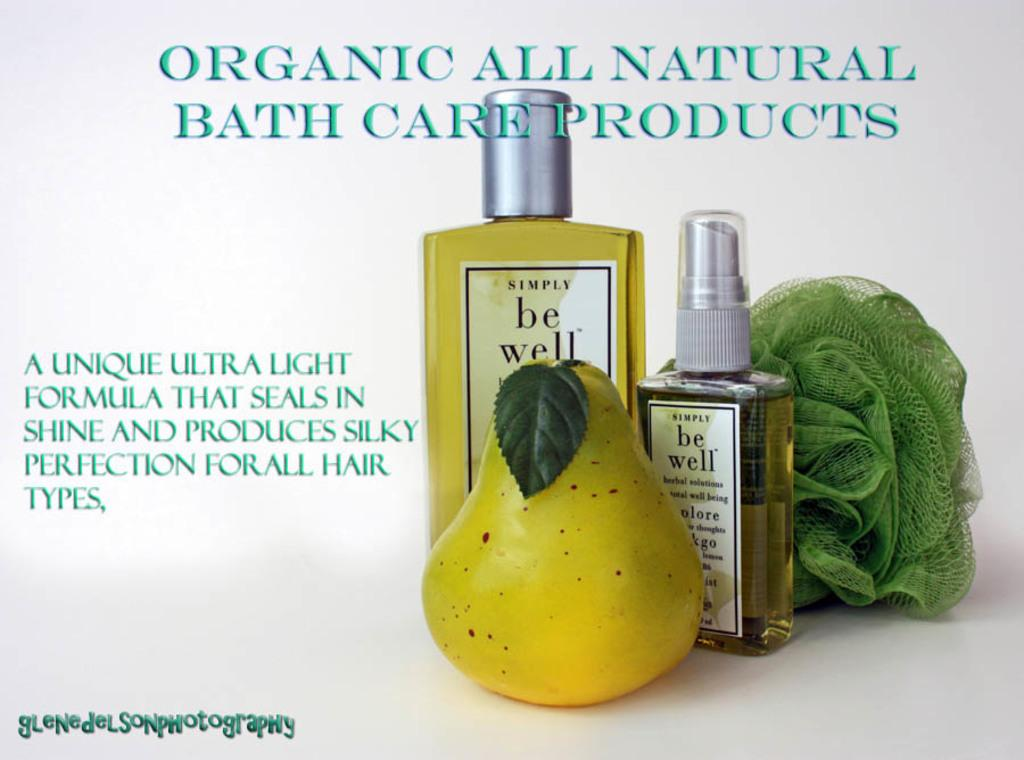<image>
Relay a brief, clear account of the picture shown. an ad for Organic All Natural Bath Care Products 